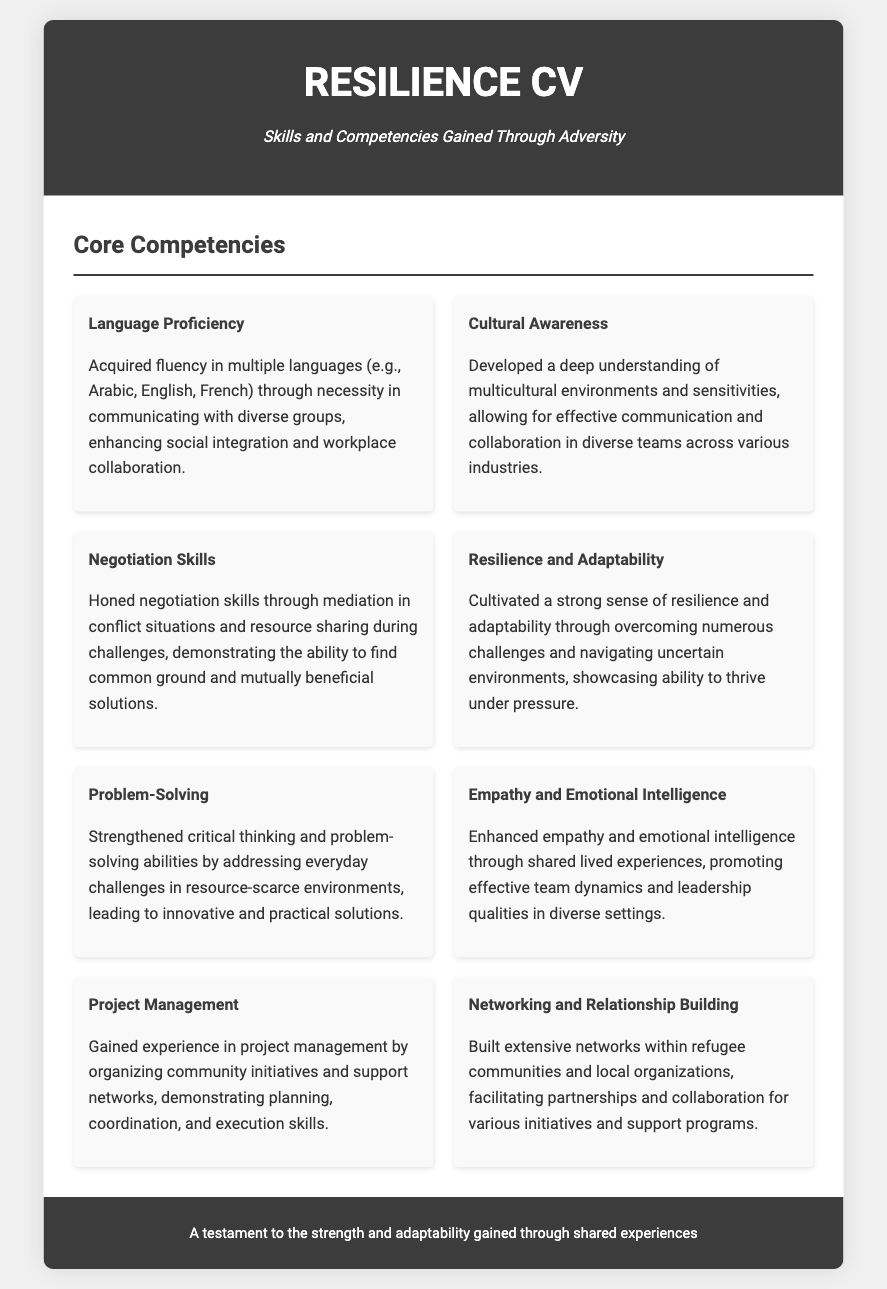What is the title of the document? The title of the document is provided in the header section of the CV.
Answer: Resilience CV How many languages were mentioned as part of language proficiency? The document highlights the acquisition of fluency in multiple languages, specifically noted are three languages.
Answer: multiple languages What skill is associated with effective communication in diverse teams? The document mentions cultural awareness as a relevant skill for effective communication in multicultural environments.
Answer: Cultural Awareness What skill emphasizes the ability to find mutual solutions? The skill related to finding common ground and mutually beneficial solutions is recognized as negotiation skills.
Answer: Negotiation Skills Which core competency reflects the ability to thrive under pressure? Resilience and adaptability are specifically described as the competency reflecting the ability to handle pressure.
Answer: Resilience and Adaptability How did the individual gain experience in project management? The experience in project management is gained through organizing community initiatives and support networks.
Answer: organizing community initiatives What does the document suggest about empathy? Enhancing empathy and emotional intelligence through shared experiences promotes effective team dynamics.
Answer: Emotional Intelligence Which skill relates to planning and execution? Project management is the skill that relates to planning, coordination, and execution of initiatives.
Answer: Project Management What is a testament to the experiences shared in the document? The footer provides a statement that reflects on the strength and adaptability gained through shared experiences.
Answer: strength and adaptability 